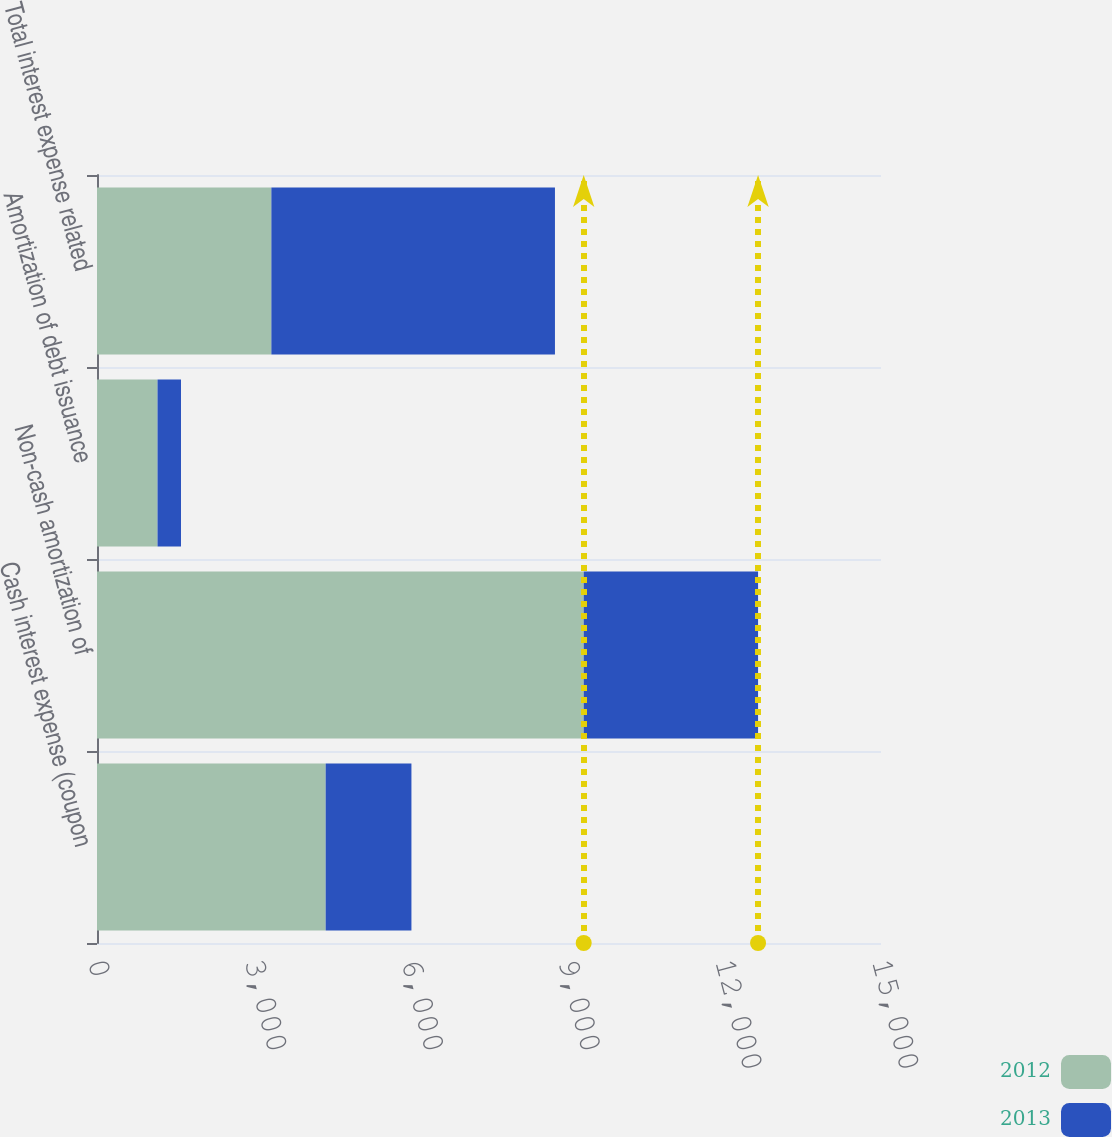Convert chart to OTSL. <chart><loc_0><loc_0><loc_500><loc_500><stacked_bar_chart><ecel><fcel>Cash interest expense (coupon<fcel>Non-cash amortization of<fcel>Amortization of debt issuance<fcel>Total interest expense related<nl><fcel>2012<fcel>4375<fcel>9312<fcel>1158<fcel>3336<nl><fcel>2013<fcel>1641<fcel>3336<fcel>449<fcel>5426<nl></chart> 